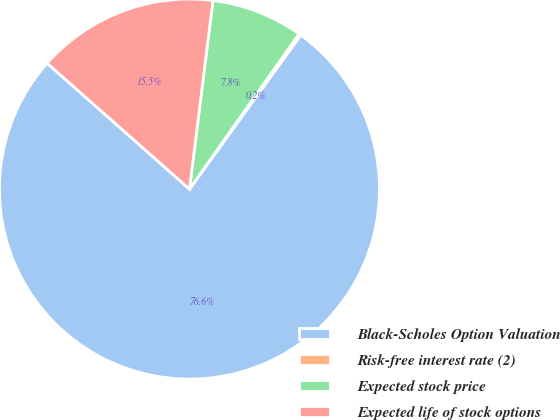Convert chart. <chart><loc_0><loc_0><loc_500><loc_500><pie_chart><fcel>Black-Scholes Option Valuation<fcel>Risk-free interest rate (2)<fcel>Expected stock price<fcel>Expected life of stock options<nl><fcel>76.56%<fcel>0.18%<fcel>7.81%<fcel>15.45%<nl></chart> 